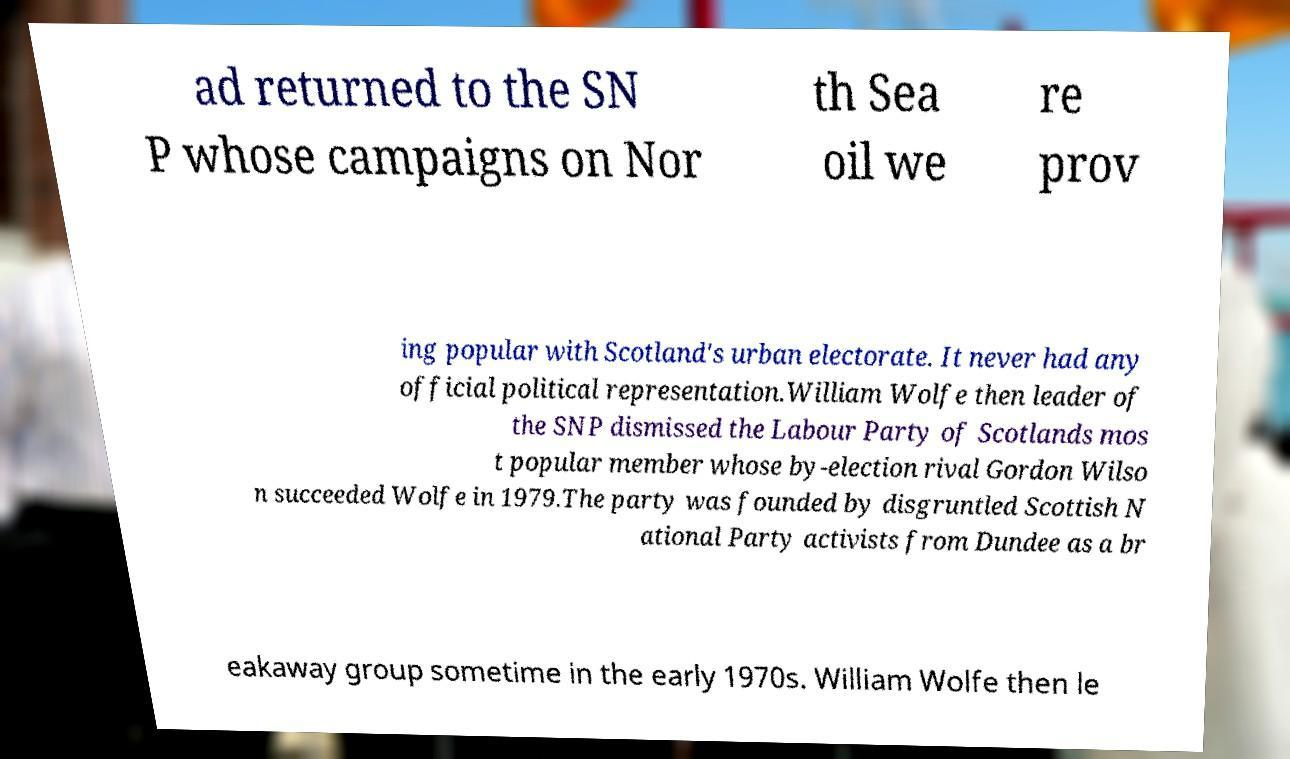Can you read and provide the text displayed in the image?This photo seems to have some interesting text. Can you extract and type it out for me? ad returned to the SN P whose campaigns on Nor th Sea oil we re prov ing popular with Scotland's urban electorate. It never had any official political representation.William Wolfe then leader of the SNP dismissed the Labour Party of Scotlands mos t popular member whose by-election rival Gordon Wilso n succeeded Wolfe in 1979.The party was founded by disgruntled Scottish N ational Party activists from Dundee as a br eakaway group sometime in the early 1970s. William Wolfe then le 